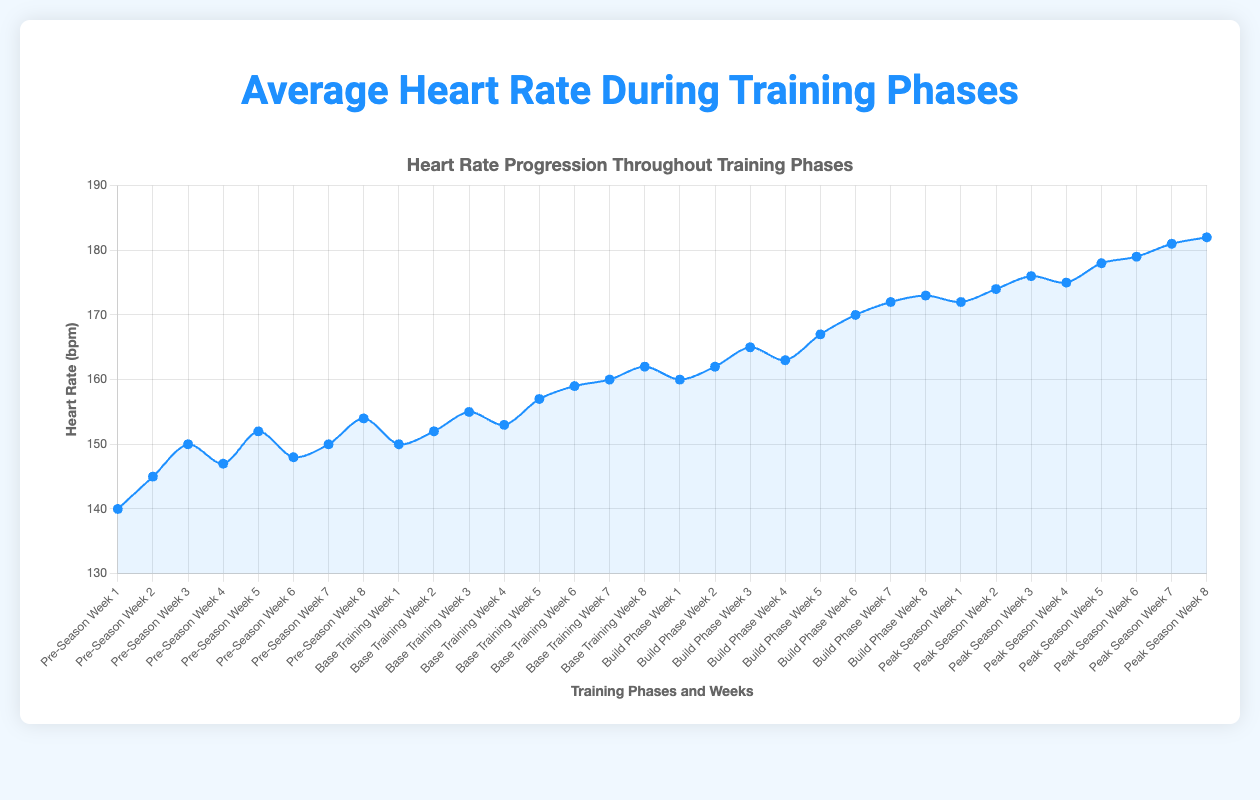What is the average heart rate in the first week of each training phase? The average heart rate for the first week of each phase can be found by looking at the heart rate values at the beginning of each training phase: Pre-Season (140), Base Training (150), Build Phase (160), and Peak Season (172). Add these values and divide by the number of phases: (140 + 150 + 160 + 172) / 4 = 155.5
Answer: 155.5 Which training phase has the highest final week average heart rate? The chart shows the final week average heart rate for each phase: Pre-Season (154), Base Training (162), Build Phase (173), and Peak Season (182). Comparing these values, Peak Season has the highest final week average heart rate.
Answer: Peak Season Comparing the first and last weeks of the Build Phase, what is the increase in average heart rate? In the Build Phase, the average heart rate starts at 160 bpm in week 1 and ends at 173 bpm in week 8. The increase is calculated by subtracting the week 1 value from the week 8 value: 173 - 160 = 13.
Answer: 13 During which week of the Base Training phase does the average heart rate first exceed 155 bpm? Reviewing the weeks in the Base Training phase, the heart rate exceeds 155 bpm in week 3 (155 bpm).
Answer: Week 3 What is the percentage increase in average heart rate from the beginning to the end of the Peak Season? The average heart rate at the beginning of Peak Season (week 1) is 172 bpm, and at the end (week 8) it is 182 bpm. The percentage increase is calculated as: ((182 - 172) / 172) * 100 ≈ 5.81%.
Answer: 5.81% Which week in the Pre-Season phase has the highest average heart rate, and what is that rate? Reviewing the Pre-Season weeks, the highest average heart rate is in week 8 with 154 bpm.
Answer: Week 8, 154 Does the average heart rate ever decrease between consecutive weeks in the Build Phase? If so, when? By examining the heart rate values in the Build Phase: week 1 (160), week 2 (162), week 3 (165), week 4 (163), week 5 (167), week 6 (170), week 7 (172), week 8 (173), it decreases from week 3 to week 4.
Answer: Week 3 to Week 4 Which two consecutive weeks across all phases have the smallest increase in average heart rate? Calculating the differences between consecutive weeks across all phases, the smallest increase is between week 3 and week 4 of the Pre-Season (150 to 147), which is a decrease of 3 bpm. Increases are positive, so finding the smallest positive value, week 2 to week 3 in Base Training (152 to 155), increase by 3 bpm.
Answer: Week 2 to Week 3 in Base Training What is the overall trend of average heart rate from Pre-Season to Peak Season? Observing the general trend in the chart, the average heart rate consistently increases from Pre-Season through Peak Season, with minor fluctuations.
Answer: Increasing trend 